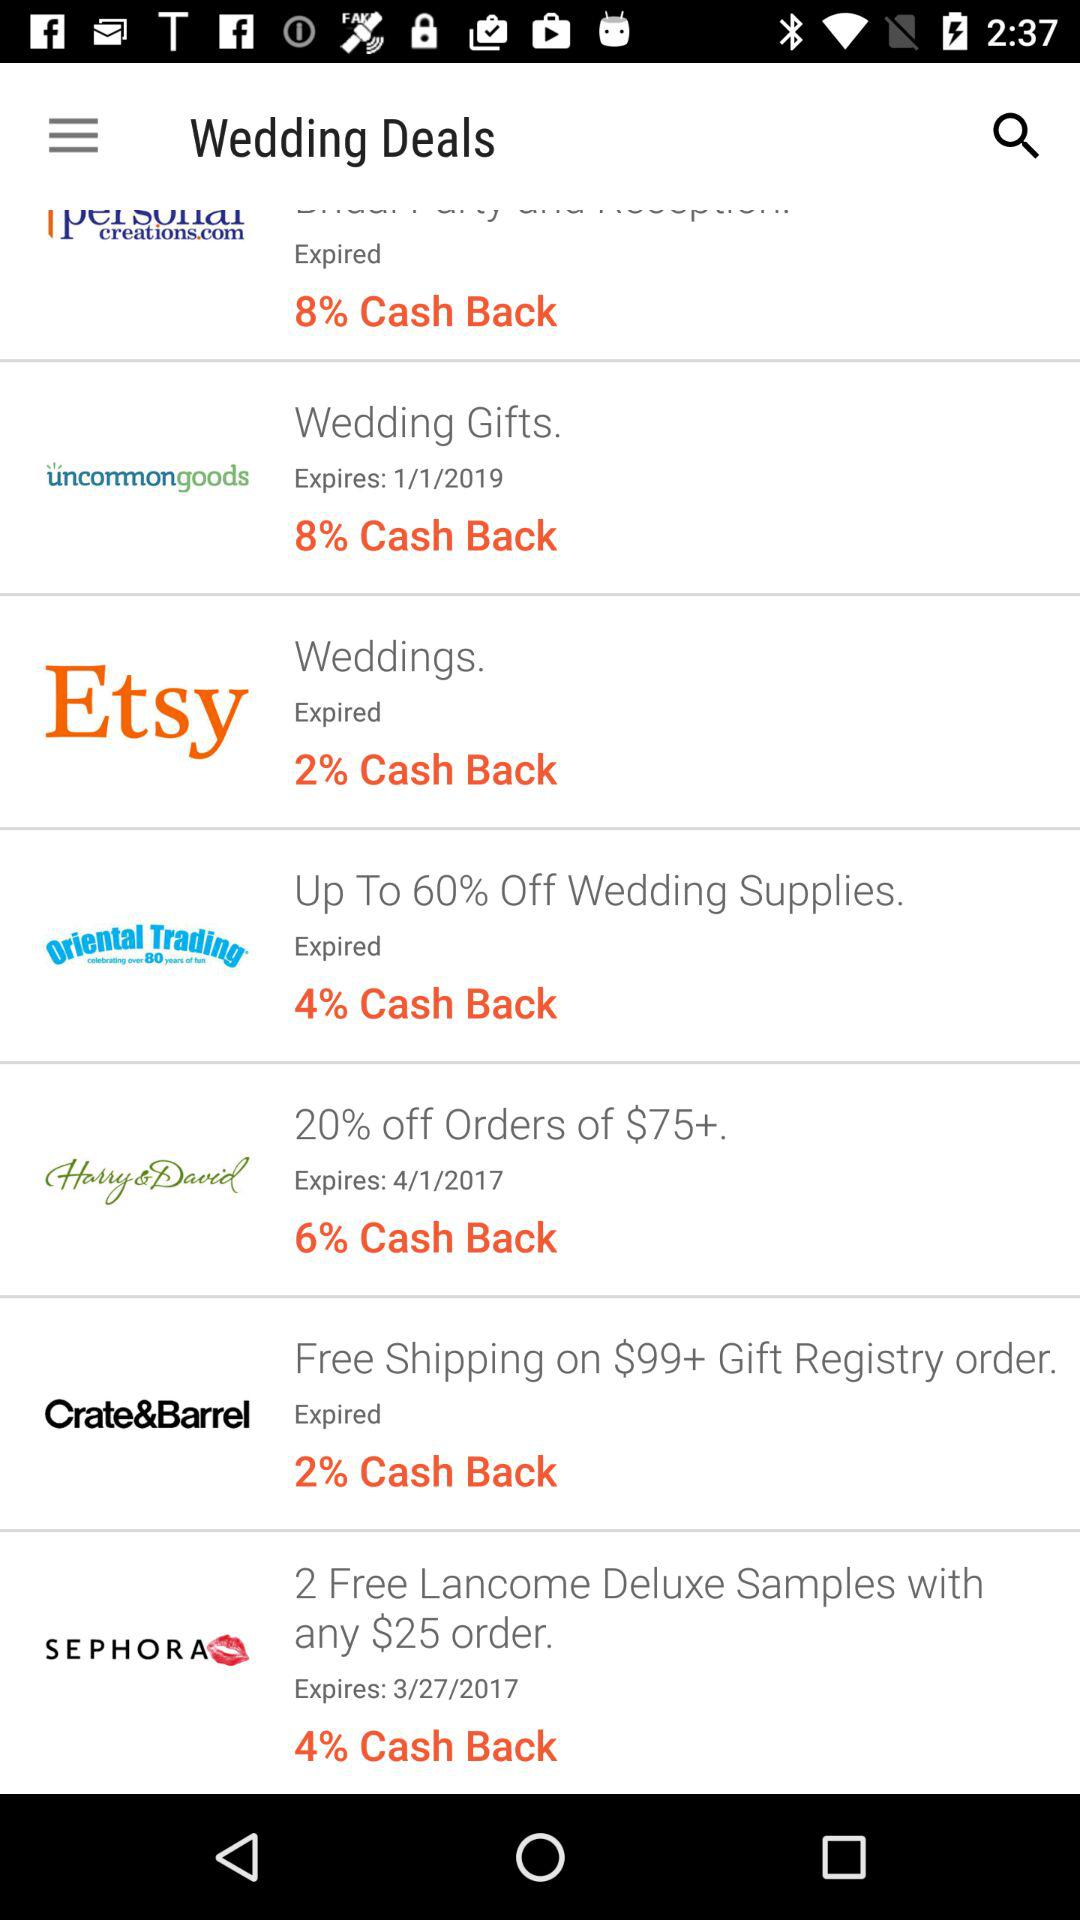When is "Wedding Gifts" cashback expiring? It is expiring on January 1, 2019. 